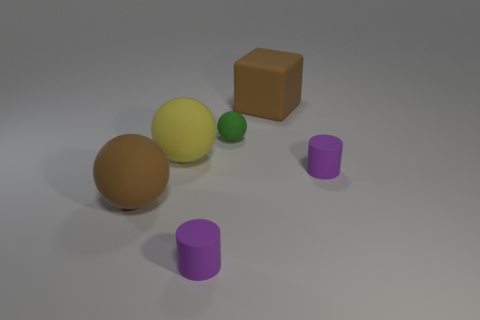Add 4 tiny cylinders. How many objects exist? 10 Subtract all cubes. How many objects are left? 5 Add 3 small green balls. How many small green balls exist? 4 Subtract 2 purple cylinders. How many objects are left? 4 Subtract all small red matte things. Subtract all large brown cubes. How many objects are left? 5 Add 3 balls. How many balls are left? 6 